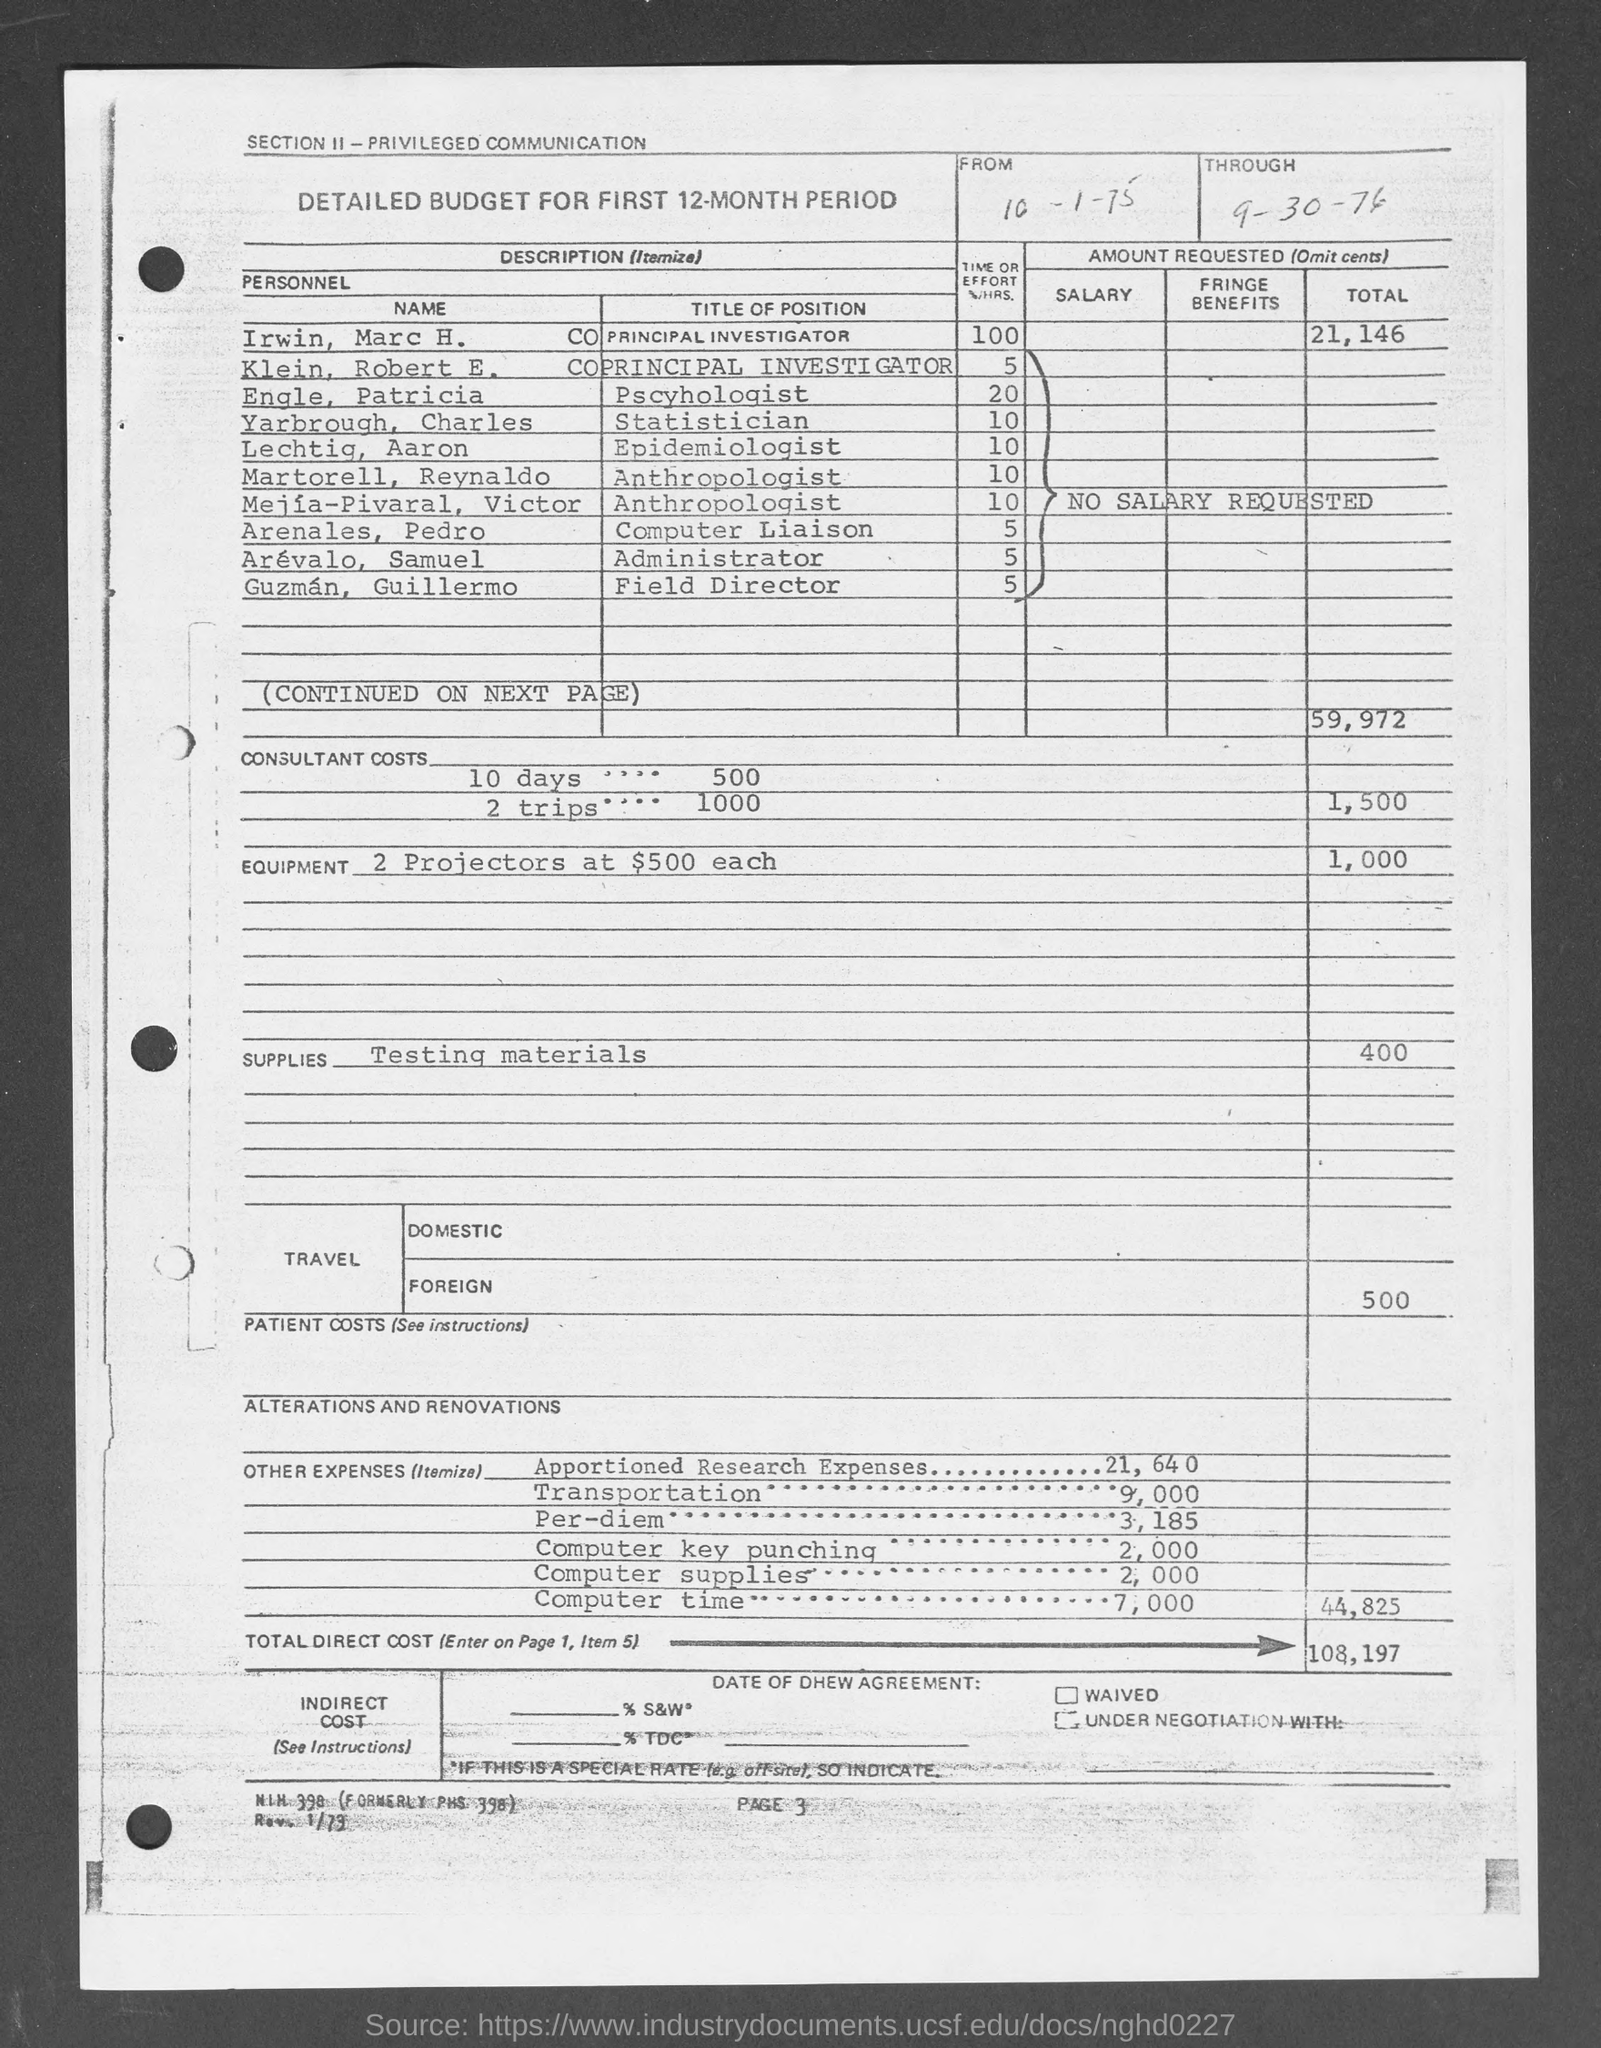What is the "Through" Date?
Your answer should be very brief. 9-30-76. What are the Consultant Costs for 10 days?
Your response must be concise. 500. What are the Consultant Costs for 2 trips?
Keep it short and to the point. 1000. What are the Costs for 2 projectors at $500 each?
Give a very brief answer. 1,000. What are the Costs for Testing Materials?
Provide a succinct answer. 400. What are the Costs for Foreign Travel?
Give a very brief answer. 500. What is the Total Direct Cost?
Keep it short and to the point. 108,197. 